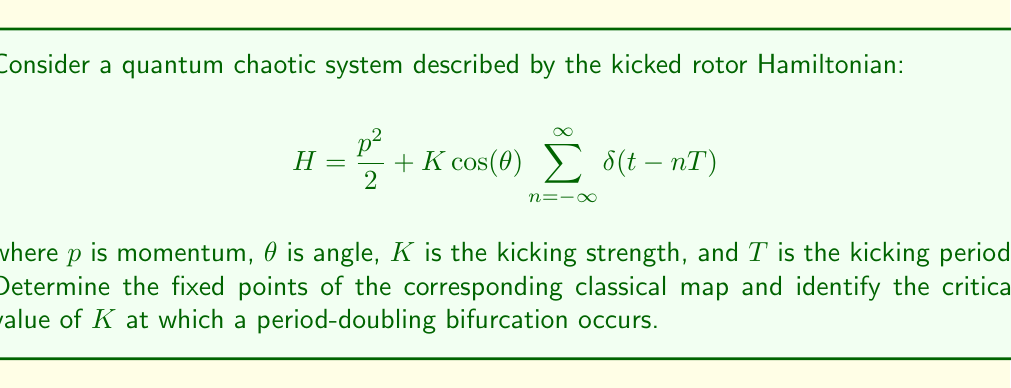Help me with this question. 1) First, we need to derive the classical map from the quantum Hamiltonian. The map is given by:

   $$\begin{aligned}
   \theta_{n+1} &= \theta_n + p_{n+1}T \mod 2\pi \\
   p_{n+1} &= p_n + K \sin(\theta_n)
   \end{aligned}$$

2) To find the fixed points, we set $\theta_{n+1} = \theta_n = \theta^*$ and $p_{n+1} = p_n = p^*$:

   $$\begin{aligned}
   \theta^* &= \theta^* + p^*T \mod 2\pi \\
   p^* &= p^* + K \sin(\theta^*)
   \end{aligned}$$

3) From the second equation, we get $\sin(\theta^*) = 0$, which implies $\theta^* = 0$ or $\pi$.

4) From the first equation, we get $p^* = 0$ (mod $2\pi/T$).

5) Therefore, the fixed points are $(\theta^*, p^*) = (0, 2\pi m/T)$ and $(\pi, 2\pi m/T)$, where $m$ is an integer.

6) To determine the stability of these fixed points and identify bifurcations, we need to calculate the Jacobian matrix:

   $$J = \begin{pmatrix}
   1 & T \\
   K \cos(\theta^*) & 1
   \end{pmatrix}$$

7) The eigenvalues of $J$ are given by:

   $$\lambda_{\pm} = 1 \pm \sqrt{KT \cos(\theta^*)}$$

8) For $\theta^* = 0$, the fixed point becomes unstable when $|\lambda_+| > 1$, which occurs when $KT > 4$.

9) For $\theta^* = \pi$, a period-doubling bifurcation occurs when $\lambda_- = -1$, which happens when $KT = 4$.

Therefore, the critical value for the period-doubling bifurcation is $K_c = 4/T$.
Answer: Fixed points: $(\theta^*, p^*) = (0, 2\pi m/T)$ and $(\pi, 2\pi m/T)$, $m \in \mathbb{Z}$. Critical value: $K_c = 4/T$. 